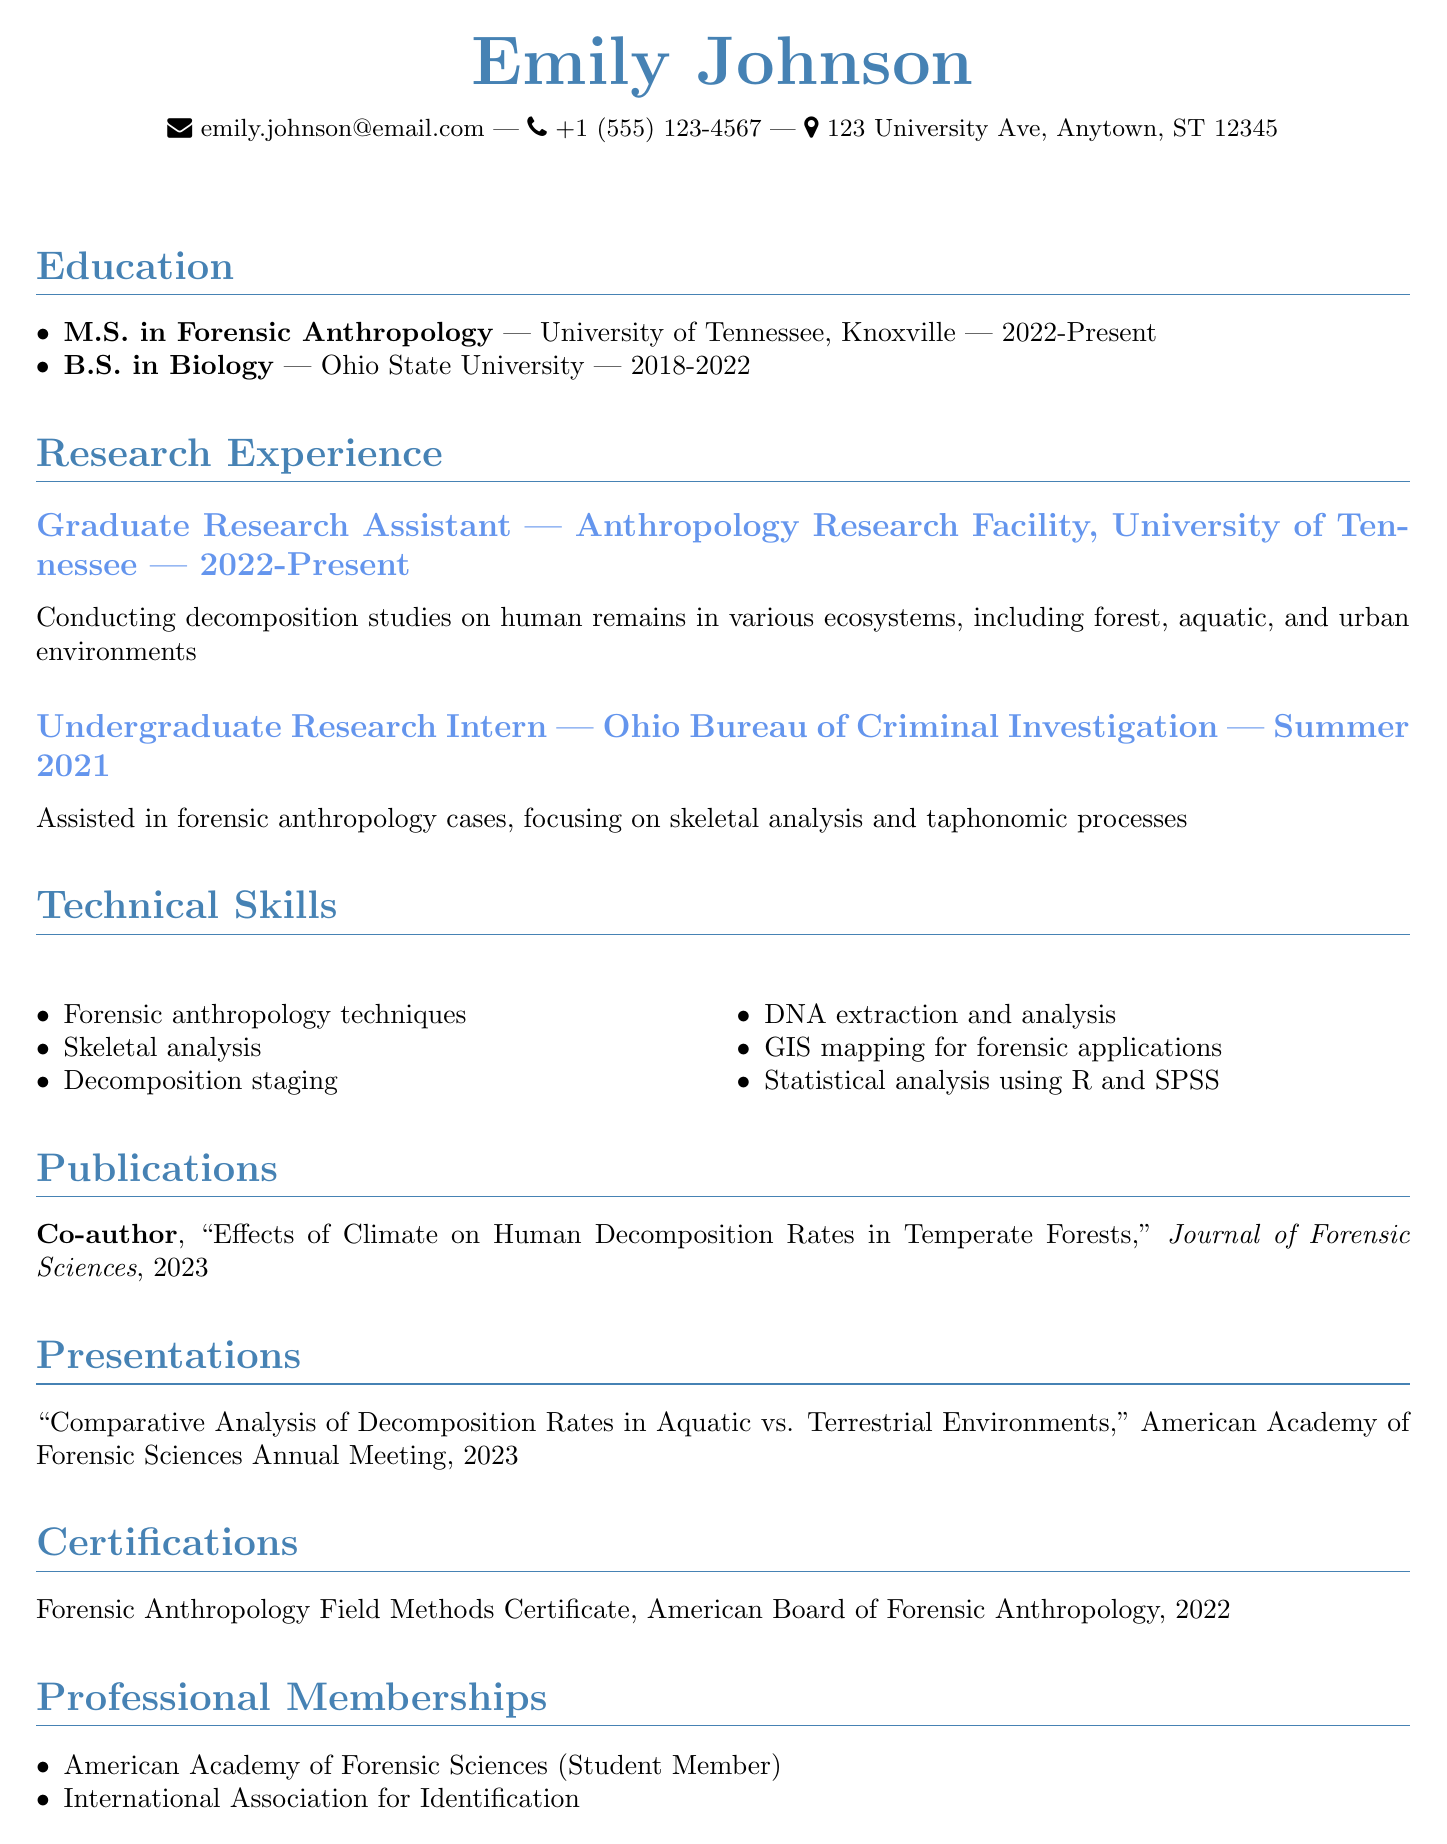what is the name of the candidate? The name of the candidate is stated at the top of the document.
Answer: Emily Johnson what degree is Emily Johnson currently pursuing? The document mentions her ongoing education at the University of Tennessee.
Answer: M.S. in Forensic Anthropology what is the title of the publication co-authored by Emily? The document provides the title of the publication under the publications section.
Answer: Effects of Climate on Human Decomposition Rates in Temperate Forests which organization issued the Forensic Anthropology Field Methods Certificate? The document specifies the institution that provided the certification.
Answer: American Board of Forensic Anthropology how long has Emily been a Graduate Research Assistant? The duration of her position is stated in the research experience section.
Answer: 2022-Present what technical skill is associated with GIS mapping? The document lists various technical skills, including one that involves geographic information systems.
Answer: GIS mapping for forensic applications how many presentations has Emily given according to this CV? The presentations section indicates the number of presentations she has made.
Answer: 1 which membership is Emily a part of that relates specifically to forensic sciences? The document lists professional memberships, highlighting her association with a particular organization.
Answer: American Academy of Forensic Sciences (Student Member) 